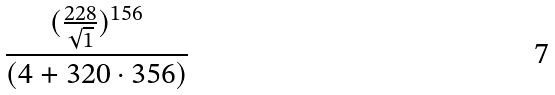Convert formula to latex. <formula><loc_0><loc_0><loc_500><loc_500>\frac { ( \frac { 2 2 8 } { \sqrt { 1 } } ) ^ { 1 5 6 } } { ( 4 + 3 2 0 \cdot 3 5 6 ) }</formula> 